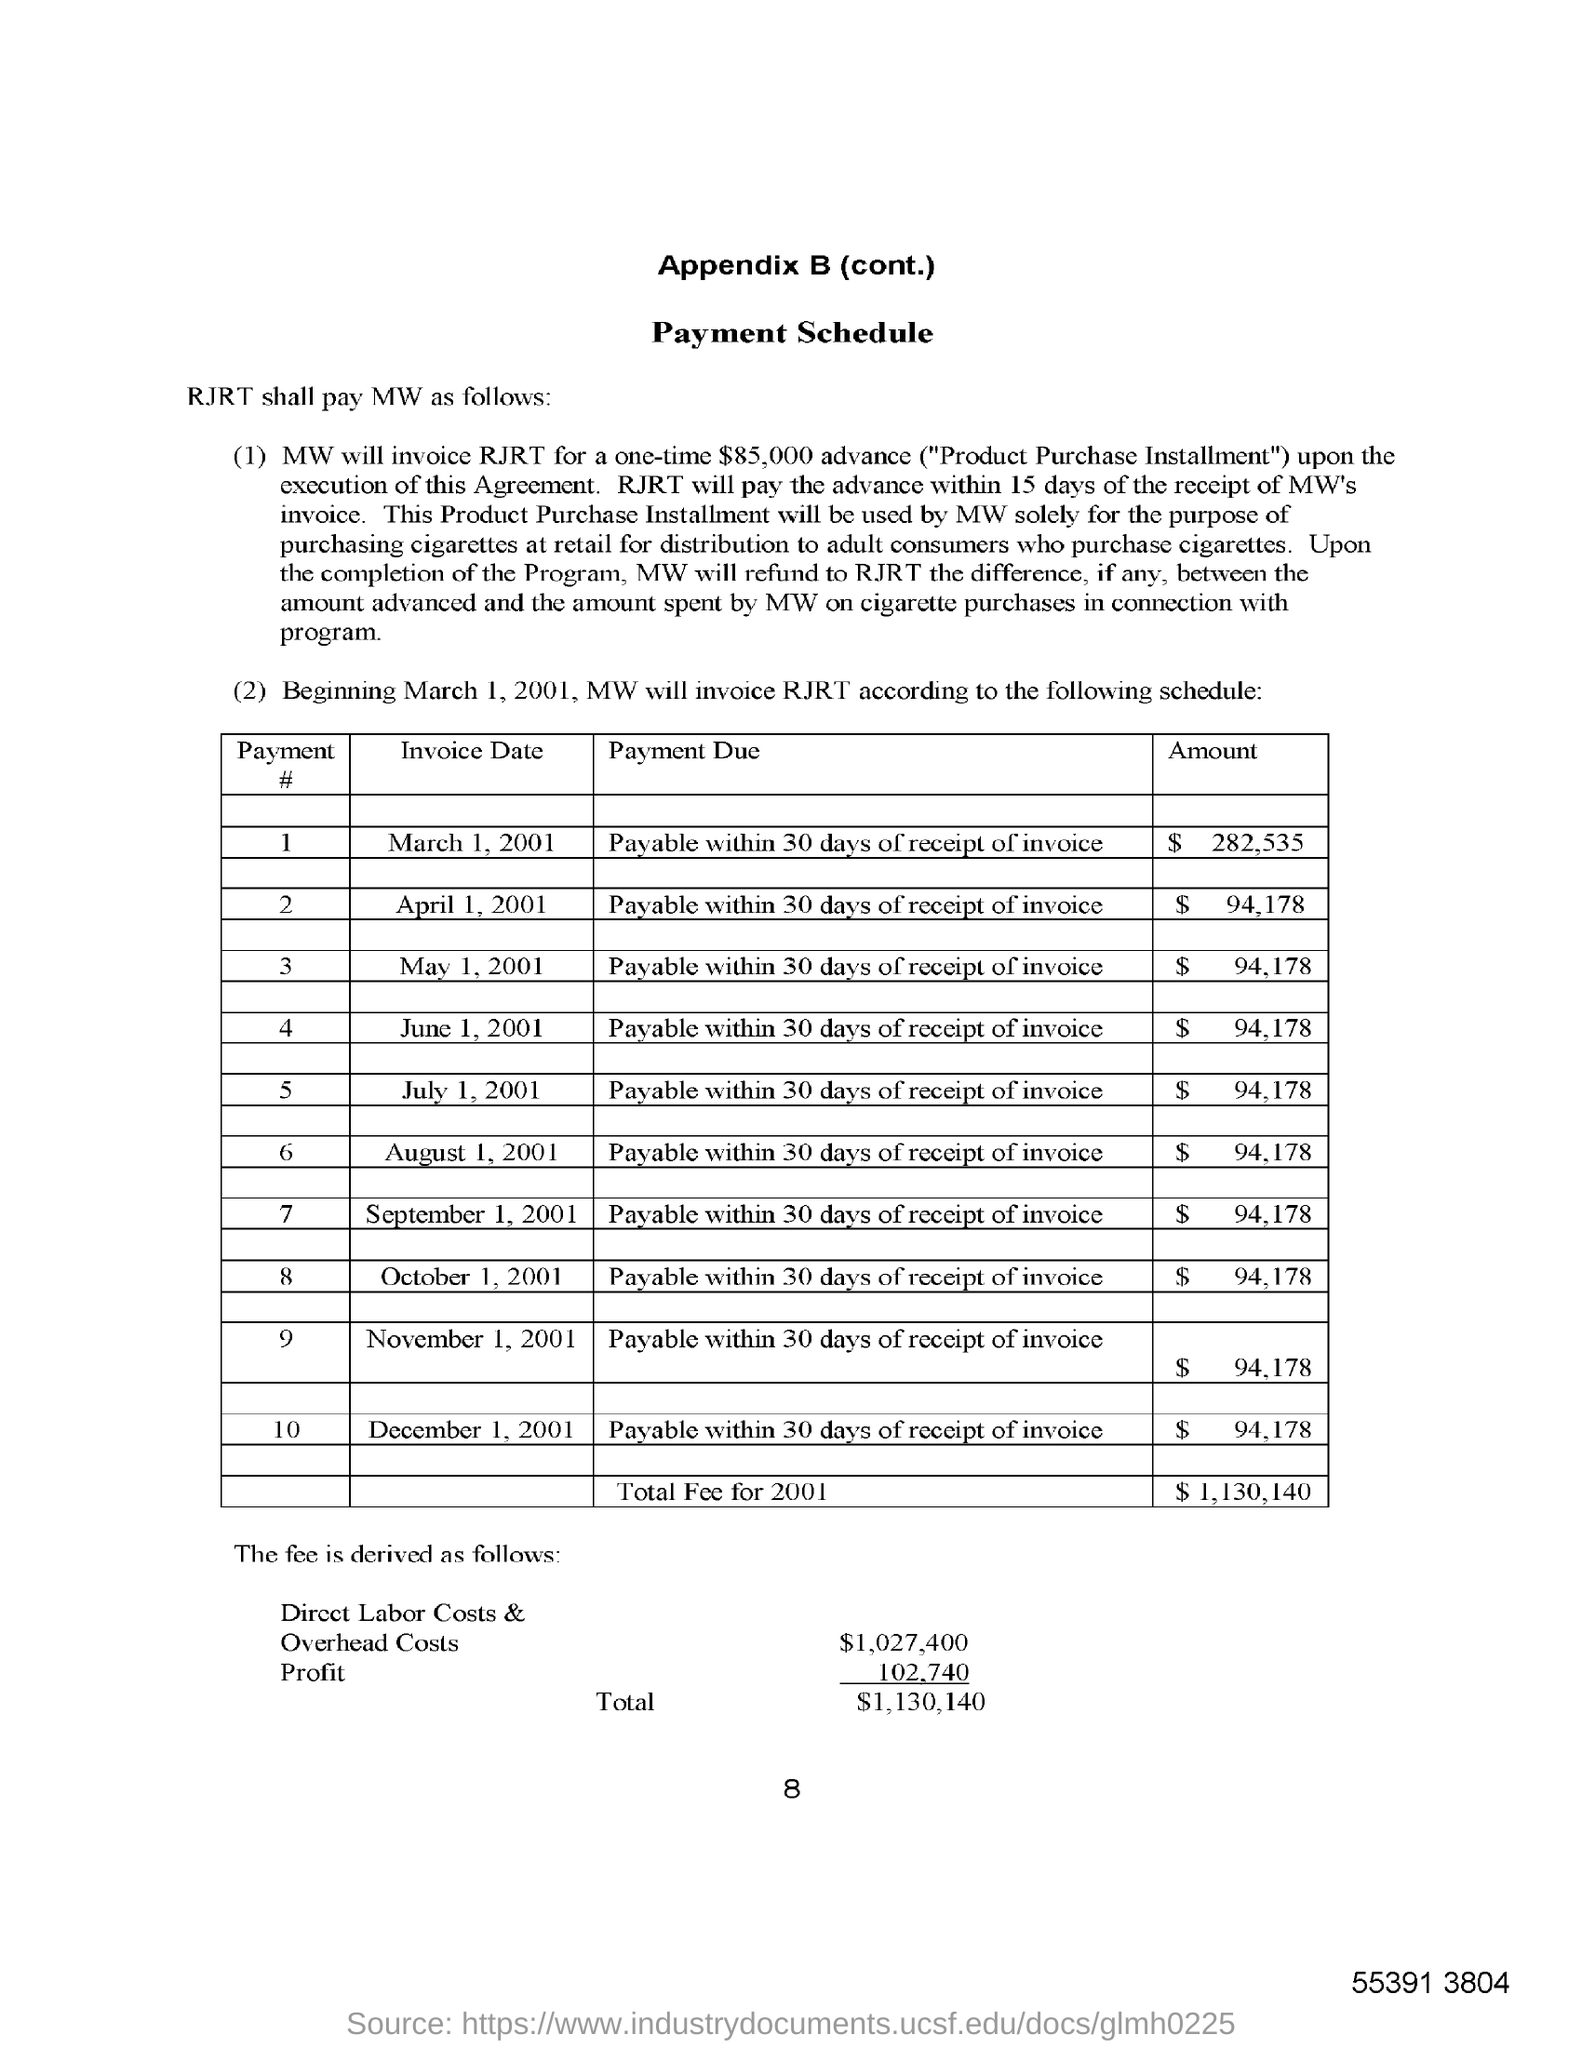Give some essential details in this illustration. The total fee for 2001 is $1,130,140. The payment for all invoices is due and payable within 30 days of receipt of the invoice. The advance amount specified as "Product Purchase Installment" is $85,000. The invoice date for the amount of $282,535 is March 1, 2001. 